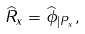<formula> <loc_0><loc_0><loc_500><loc_500>\widehat { R } _ { x } = \widehat { \phi } _ { | P _ { x } } ,</formula> 